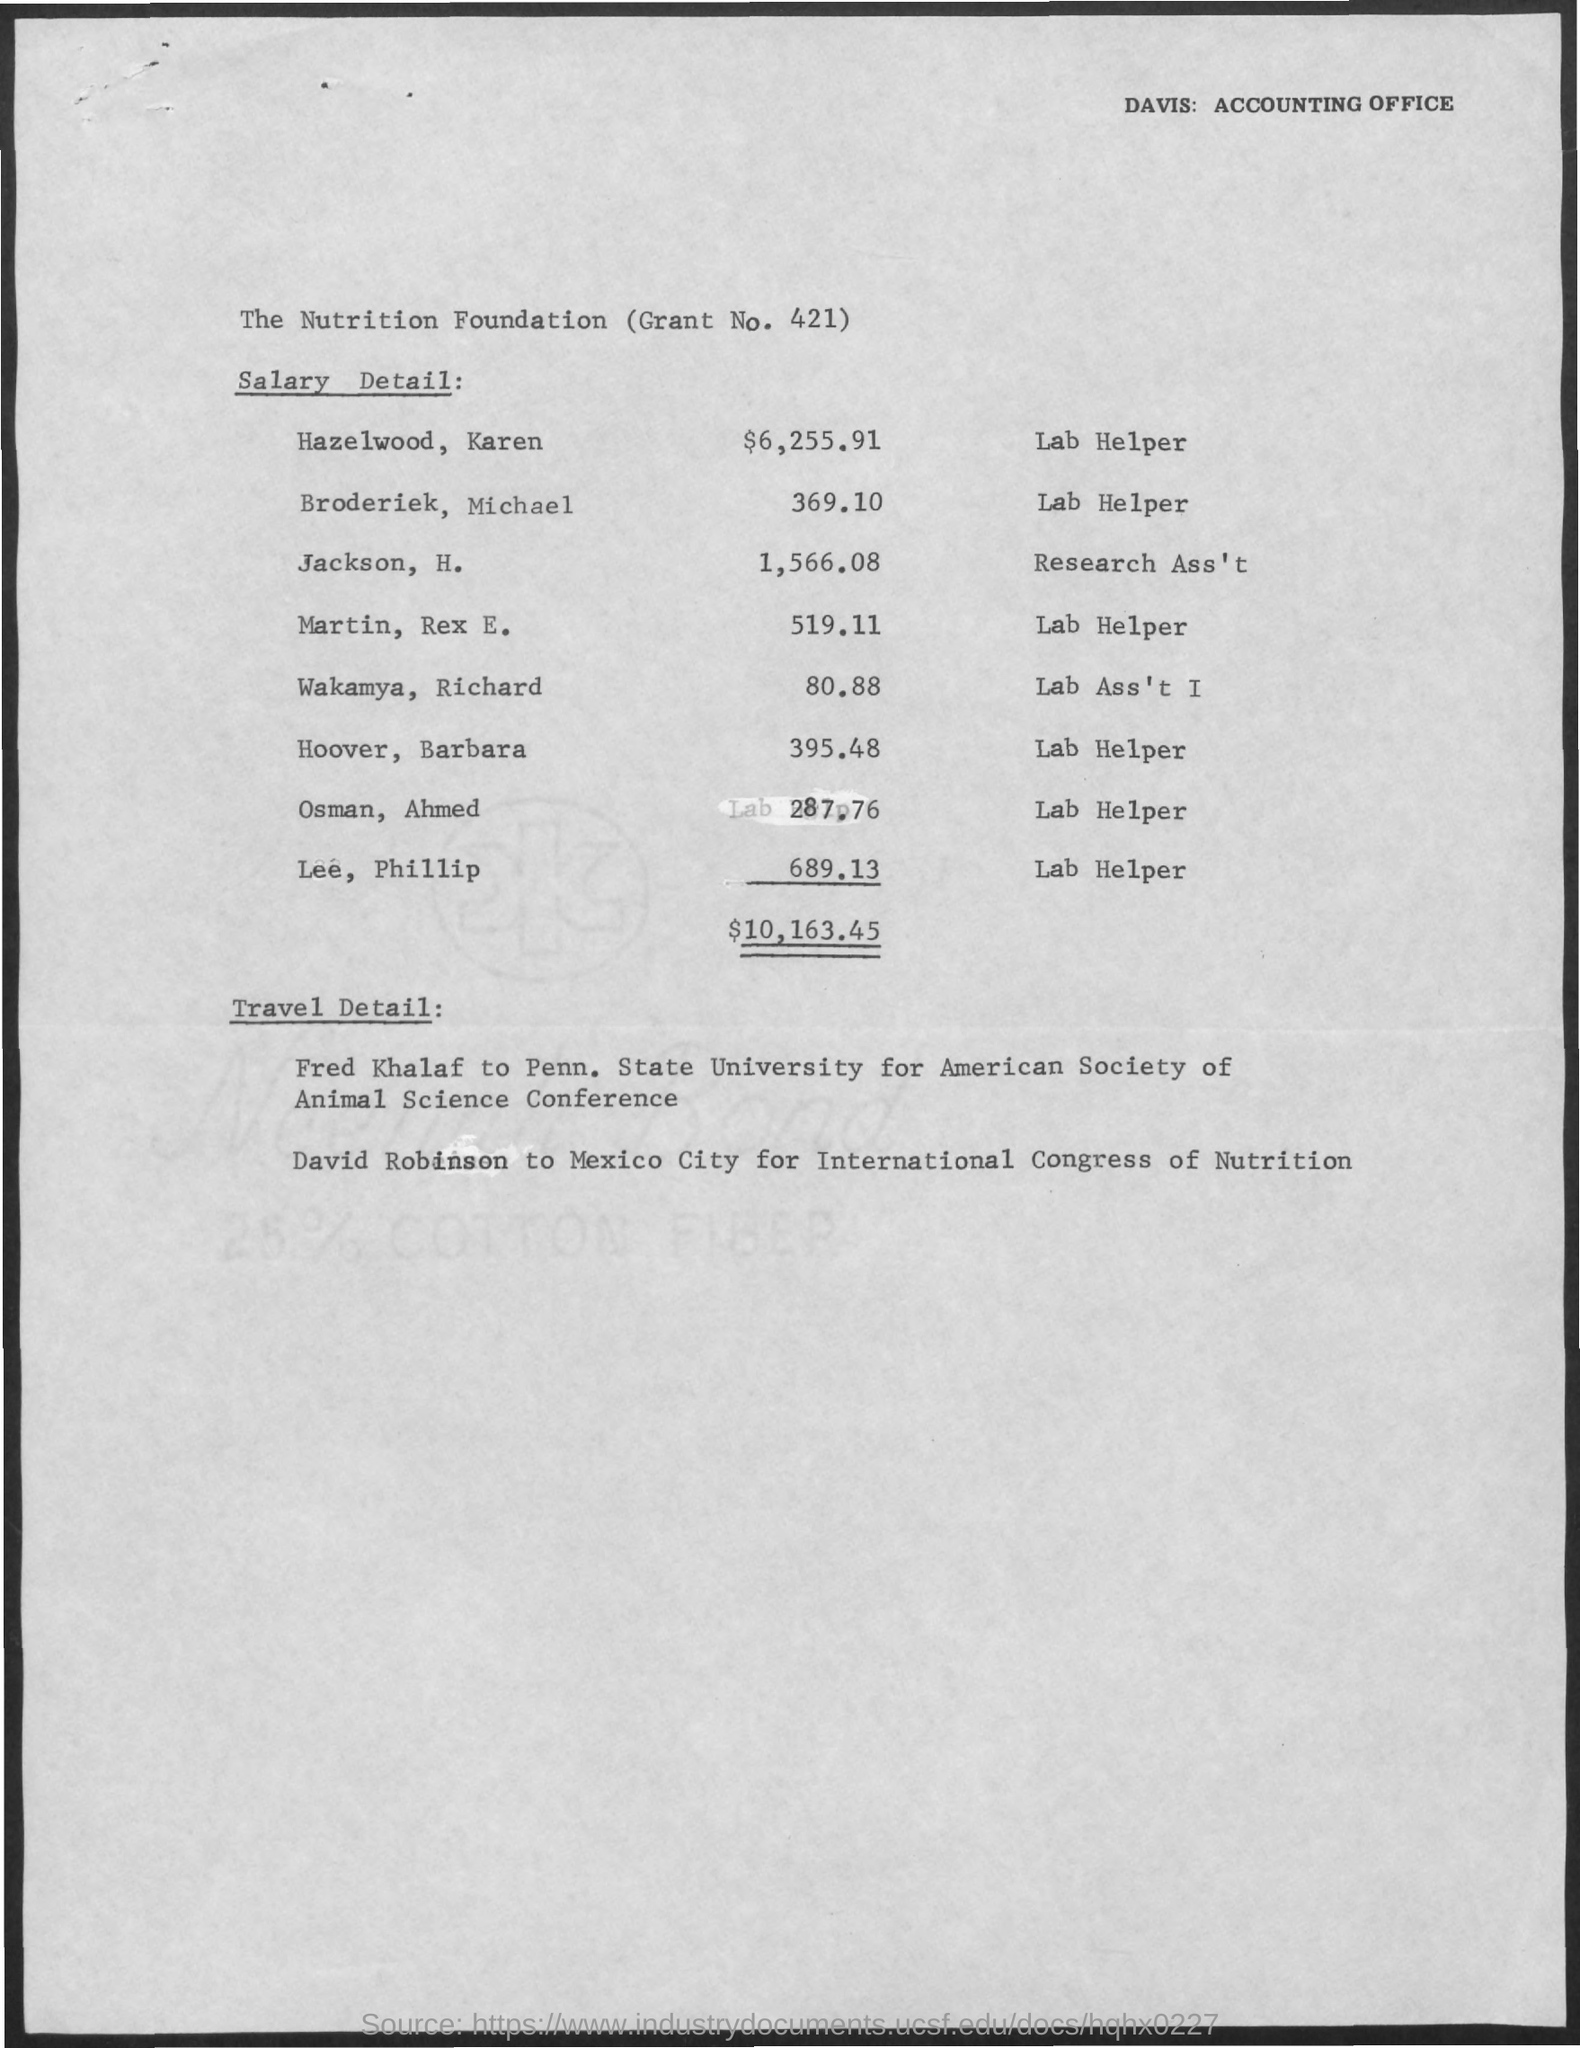What is the Salary for Hazelwood, Karen?
Your answer should be compact. $6,225.91. What is the Salary for Broderiek, Michael?
Your answer should be compact. 369.10. What is the Salary for Jackson, H.?
Provide a short and direct response. 1,566.08. What is the Salary for Martin, Rex E.?
Provide a short and direct response. 519.11. What is the Salary for Wakamya, Richard?
Offer a very short reply. 80.88. What is the Salary for Hoover, Barbara?
Your answer should be compact. 395.48. What is the Salary for Osman, Ahmed?
Give a very brief answer. 287.76. What is the Salary for Lee, Phillip?
Offer a very short reply. 689.13. 